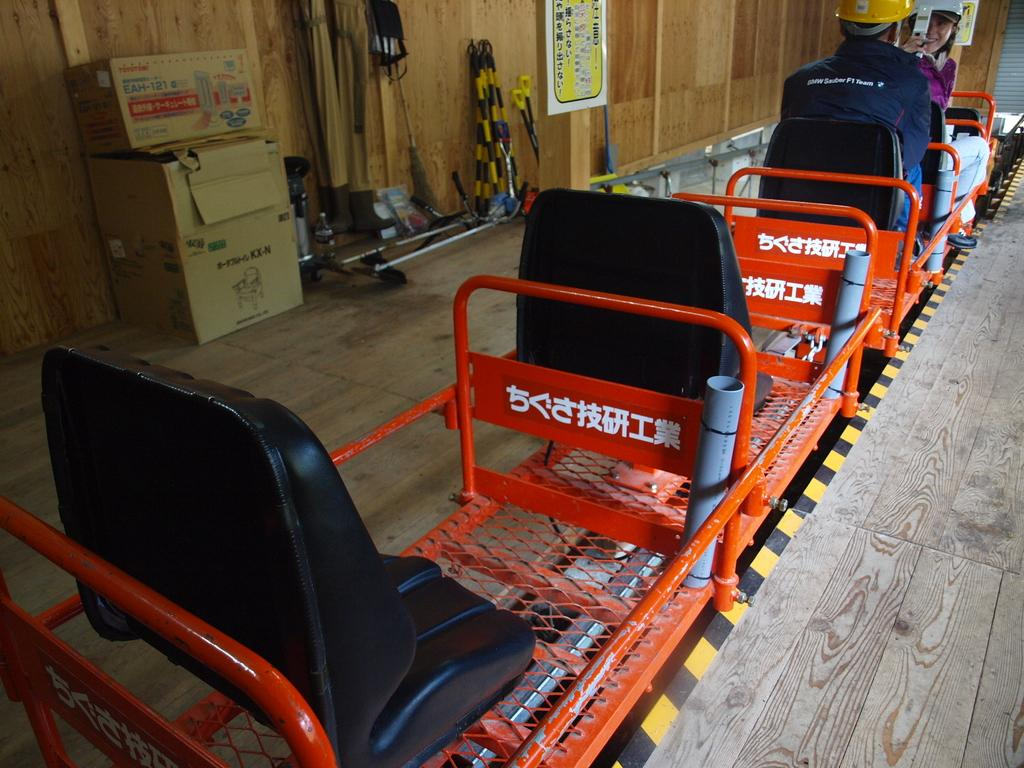What are the persons in the image doing? The persons in the image are sitting on the seats of a trolley. What type of containers can be seen in the image? Cardboard cartons are present in the image. What is visible on the trolley or nearby? There is an advertisement visible. What tools are related to gardening and present in the image? Gardening tools are in the image. What surface can be seen beneath the trolley and other objects? The floor is visible. What type of sweater is being worn by the person in the image? There is no person wearing a sweater in the image; the focus is on the persons sitting on the trolley and the surrounding objects. 